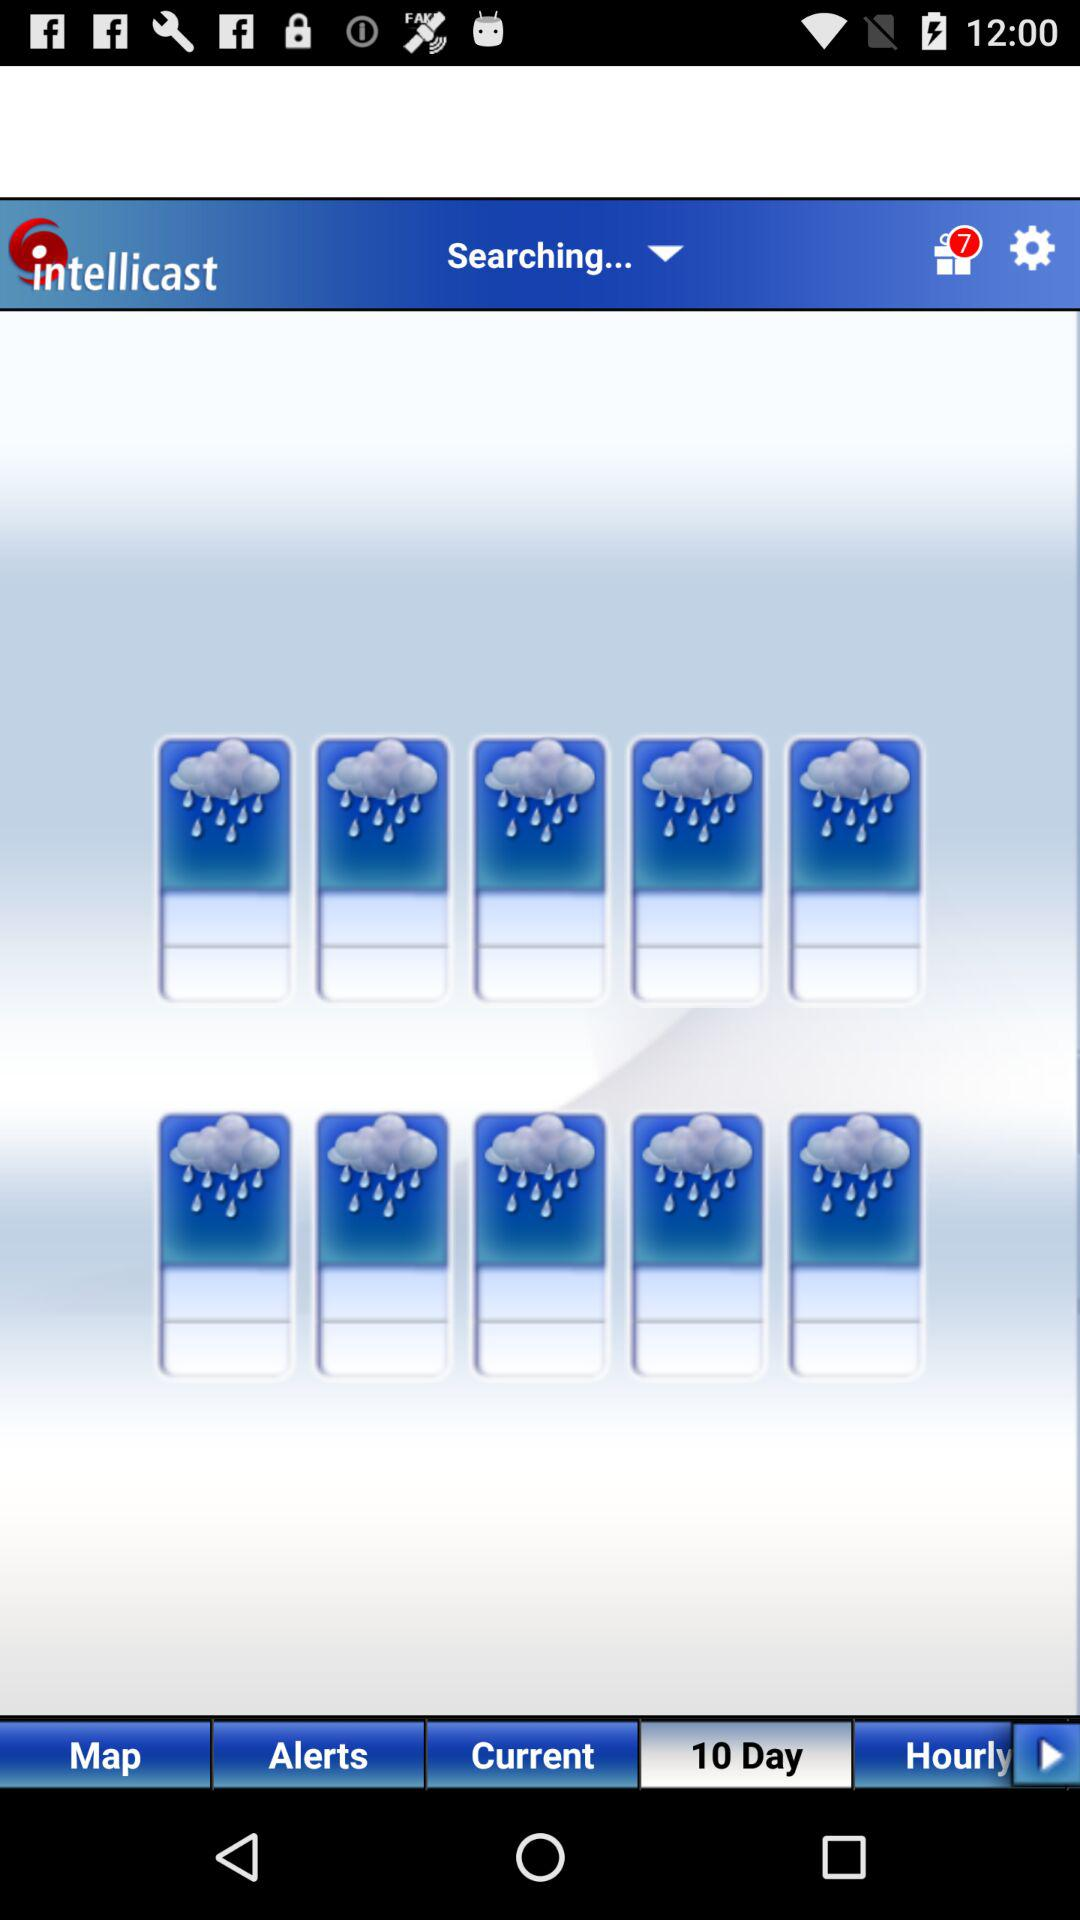Which tab am I on? You are on the "10 Day" tab. 